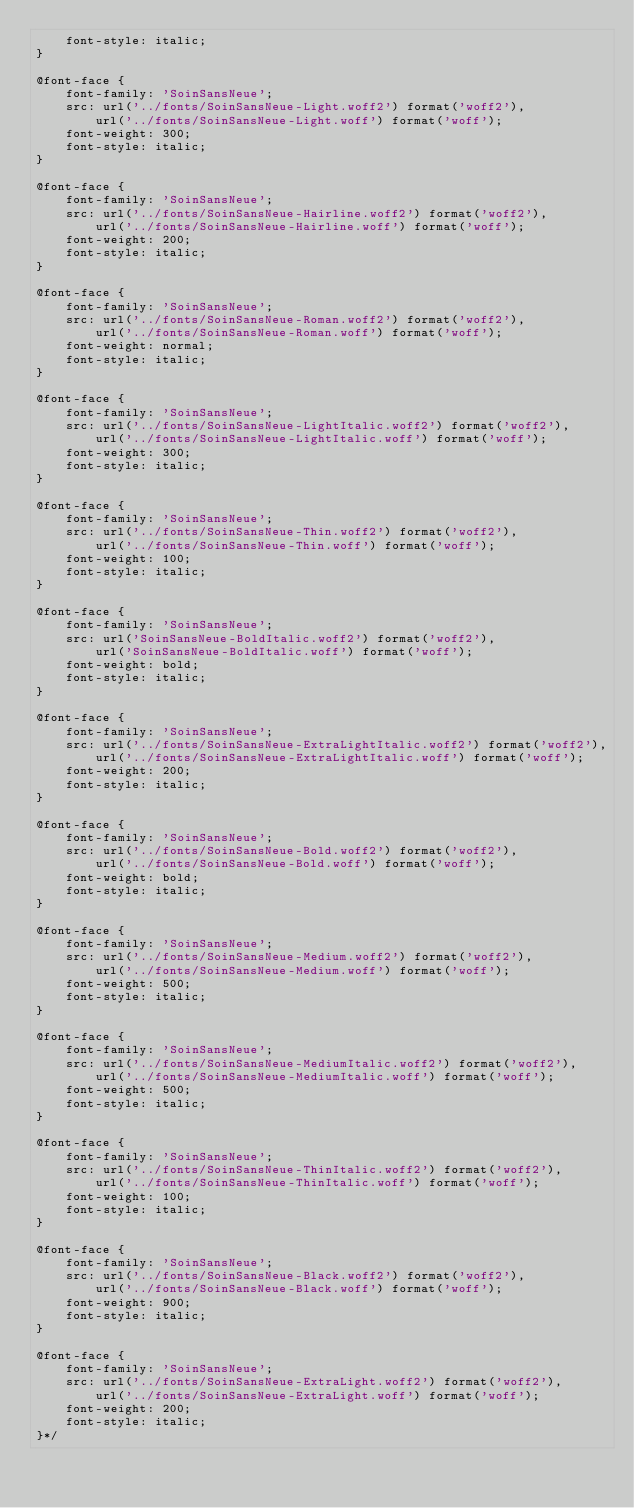Convert code to text. <code><loc_0><loc_0><loc_500><loc_500><_CSS_>    font-style: italic;
}

@font-face {
    font-family: 'SoinSansNeue';
    src: url('../fonts/SoinSansNeue-Light.woff2') format('woff2'),
        url('../fonts/SoinSansNeue-Light.woff') format('woff');
    font-weight: 300;
    font-style: italic;
}

@font-face {
    font-family: 'SoinSansNeue';
    src: url('../fonts/SoinSansNeue-Hairline.woff2') format('woff2'),
        url('../fonts/SoinSansNeue-Hairline.woff') format('woff');
    font-weight: 200;
    font-style: italic;
}

@font-face {
    font-family: 'SoinSansNeue';
    src: url('../fonts/SoinSansNeue-Roman.woff2') format('woff2'),
        url('../fonts/SoinSansNeue-Roman.woff') format('woff');
    font-weight: normal;
    font-style: italic;
}

@font-face {
    font-family: 'SoinSansNeue';
    src: url('../fonts/SoinSansNeue-LightItalic.woff2') format('woff2'),
        url('../fonts/SoinSansNeue-LightItalic.woff') format('woff');
    font-weight: 300;
    font-style: italic;
}

@font-face {
    font-family: 'SoinSansNeue';
    src: url('../fonts/SoinSansNeue-Thin.woff2') format('woff2'),
        url('../fonts/SoinSansNeue-Thin.woff') format('woff');
    font-weight: 100;
    font-style: italic;
}

@font-face {
    font-family: 'SoinSansNeue';
    src: url('SoinSansNeue-BoldItalic.woff2') format('woff2'),
        url('SoinSansNeue-BoldItalic.woff') format('woff');
    font-weight: bold;
    font-style: italic;
}

@font-face {
    font-family: 'SoinSansNeue';
    src: url('../fonts/SoinSansNeue-ExtraLightItalic.woff2') format('woff2'),
        url('../fonts/SoinSansNeue-ExtraLightItalic.woff') format('woff');
    font-weight: 200;
    font-style: italic;
}

@font-face {
    font-family: 'SoinSansNeue';
    src: url('../fonts/SoinSansNeue-Bold.woff2') format('woff2'),
        url('../fonts/SoinSansNeue-Bold.woff') format('woff');
    font-weight: bold;
    font-style: italic;
}

@font-face {
    font-family: 'SoinSansNeue';
    src: url('../fonts/SoinSansNeue-Medium.woff2') format('woff2'),
        url('../fonts/SoinSansNeue-Medium.woff') format('woff');
    font-weight: 500;
    font-style: italic;
}

@font-face {
    font-family: 'SoinSansNeue';
    src: url('../fonts/SoinSansNeue-MediumItalic.woff2') format('woff2'),
        url('../fonts/SoinSansNeue-MediumItalic.woff') format('woff');
    font-weight: 500;
    font-style: italic;
}

@font-face {
    font-family: 'SoinSansNeue';
    src: url('../fonts/SoinSansNeue-ThinItalic.woff2') format('woff2'),
        url('../fonts/SoinSansNeue-ThinItalic.woff') format('woff');
    font-weight: 100;
    font-style: italic;
}

@font-face {
    font-family: 'SoinSansNeue';
    src: url('../fonts/SoinSansNeue-Black.woff2') format('woff2'),
        url('../fonts/SoinSansNeue-Black.woff') format('woff');
    font-weight: 900;
    font-style: italic;
}

@font-face {
    font-family: 'SoinSansNeue';
    src: url('../fonts/SoinSansNeue-ExtraLight.woff2') format('woff2'),
        url('../fonts/SoinSansNeue-ExtraLight.woff') format('woff');
    font-weight: 200;
    font-style: italic;
}*/</code> 